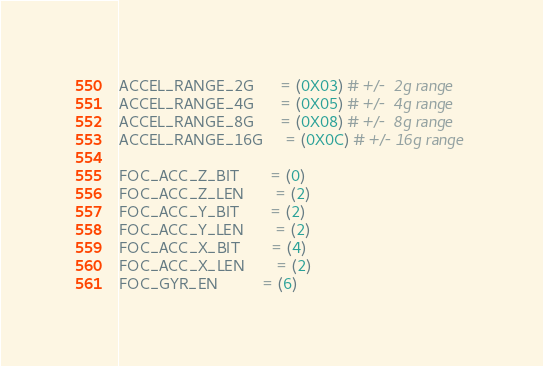Convert code to text. <code><loc_0><loc_0><loc_500><loc_500><_Python_>ACCEL_RANGE_2G      = (0X03) # +/-  2g range
ACCEL_RANGE_4G      = (0X05) # +/-  4g range
ACCEL_RANGE_8G      = (0X08) # +/-  8g range
ACCEL_RANGE_16G     = (0X0C) # +/- 16g range

FOC_ACC_Z_BIT       = (0)
FOC_ACC_Z_LEN       = (2)
FOC_ACC_Y_BIT       = (2)
FOC_ACC_Y_LEN       = (2)
FOC_ACC_X_BIT       = (4)
FOC_ACC_X_LEN       = (2)
FOC_GYR_EN          = (6)</code> 